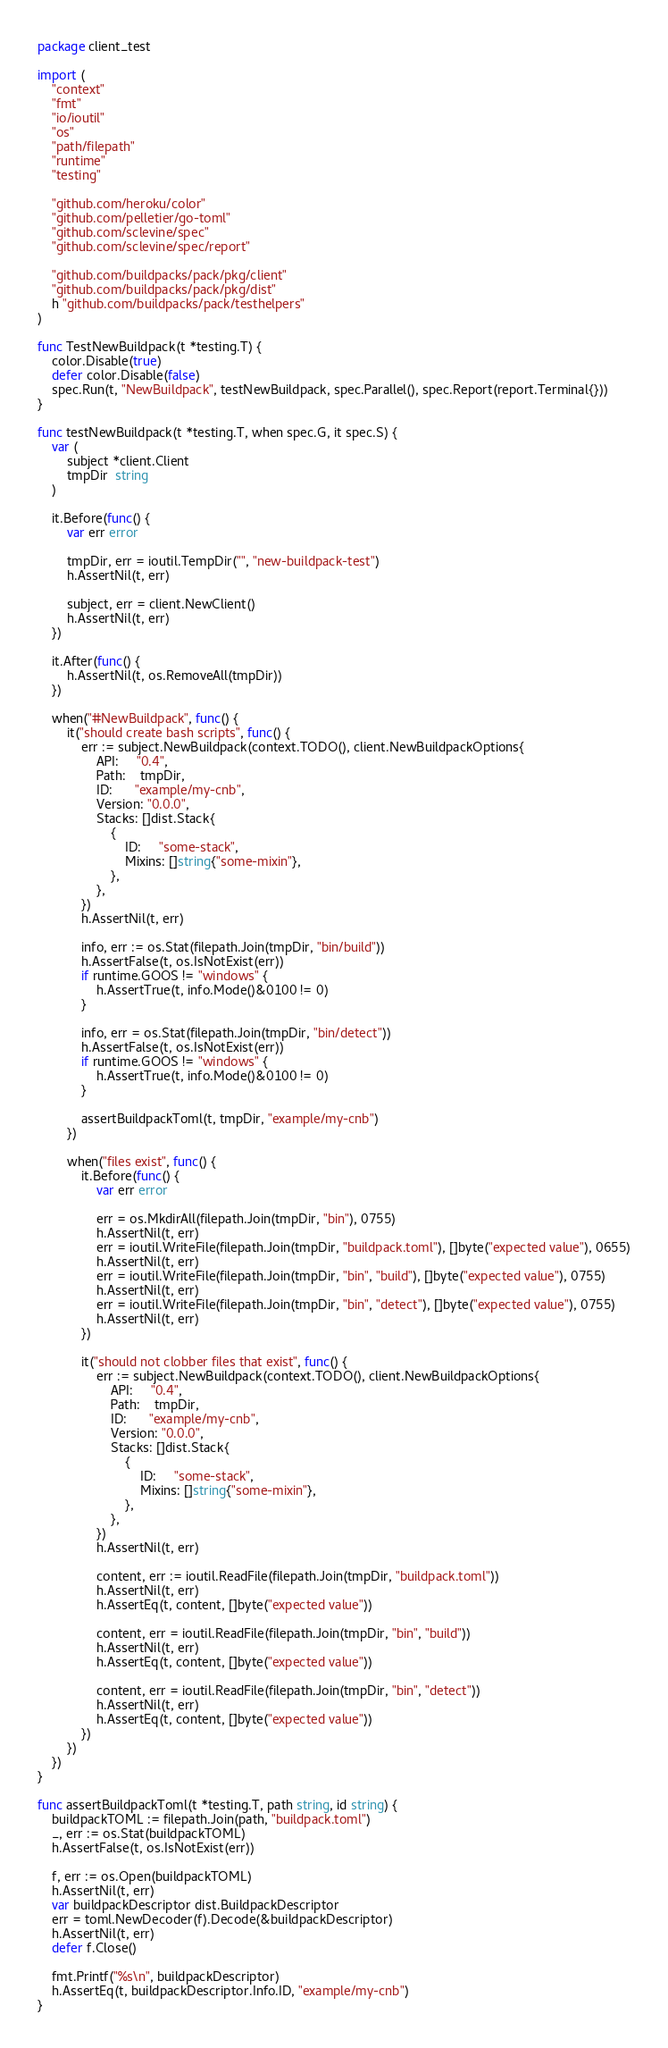Convert code to text. <code><loc_0><loc_0><loc_500><loc_500><_Go_>package client_test

import (
	"context"
	"fmt"
	"io/ioutil"
	"os"
	"path/filepath"
	"runtime"
	"testing"

	"github.com/heroku/color"
	"github.com/pelletier/go-toml"
	"github.com/sclevine/spec"
	"github.com/sclevine/spec/report"

	"github.com/buildpacks/pack/pkg/client"
	"github.com/buildpacks/pack/pkg/dist"
	h "github.com/buildpacks/pack/testhelpers"
)

func TestNewBuildpack(t *testing.T) {
	color.Disable(true)
	defer color.Disable(false)
	spec.Run(t, "NewBuildpack", testNewBuildpack, spec.Parallel(), spec.Report(report.Terminal{}))
}

func testNewBuildpack(t *testing.T, when spec.G, it spec.S) {
	var (
		subject *client.Client
		tmpDir  string
	)

	it.Before(func() {
		var err error

		tmpDir, err = ioutil.TempDir("", "new-buildpack-test")
		h.AssertNil(t, err)

		subject, err = client.NewClient()
		h.AssertNil(t, err)
	})

	it.After(func() {
		h.AssertNil(t, os.RemoveAll(tmpDir))
	})

	when("#NewBuildpack", func() {
		it("should create bash scripts", func() {
			err := subject.NewBuildpack(context.TODO(), client.NewBuildpackOptions{
				API:     "0.4",
				Path:    tmpDir,
				ID:      "example/my-cnb",
				Version: "0.0.0",
				Stacks: []dist.Stack{
					{
						ID:     "some-stack",
						Mixins: []string{"some-mixin"},
					},
				},
			})
			h.AssertNil(t, err)

			info, err := os.Stat(filepath.Join(tmpDir, "bin/build"))
			h.AssertFalse(t, os.IsNotExist(err))
			if runtime.GOOS != "windows" {
				h.AssertTrue(t, info.Mode()&0100 != 0)
			}

			info, err = os.Stat(filepath.Join(tmpDir, "bin/detect"))
			h.AssertFalse(t, os.IsNotExist(err))
			if runtime.GOOS != "windows" {
				h.AssertTrue(t, info.Mode()&0100 != 0)
			}

			assertBuildpackToml(t, tmpDir, "example/my-cnb")
		})

		when("files exist", func() {
			it.Before(func() {
				var err error

				err = os.MkdirAll(filepath.Join(tmpDir, "bin"), 0755)
				h.AssertNil(t, err)
				err = ioutil.WriteFile(filepath.Join(tmpDir, "buildpack.toml"), []byte("expected value"), 0655)
				h.AssertNil(t, err)
				err = ioutil.WriteFile(filepath.Join(tmpDir, "bin", "build"), []byte("expected value"), 0755)
				h.AssertNil(t, err)
				err = ioutil.WriteFile(filepath.Join(tmpDir, "bin", "detect"), []byte("expected value"), 0755)
				h.AssertNil(t, err)
			})

			it("should not clobber files that exist", func() {
				err := subject.NewBuildpack(context.TODO(), client.NewBuildpackOptions{
					API:     "0.4",
					Path:    tmpDir,
					ID:      "example/my-cnb",
					Version: "0.0.0",
					Stacks: []dist.Stack{
						{
							ID:     "some-stack",
							Mixins: []string{"some-mixin"},
						},
					},
				})
				h.AssertNil(t, err)

				content, err := ioutil.ReadFile(filepath.Join(tmpDir, "buildpack.toml"))
				h.AssertNil(t, err)
				h.AssertEq(t, content, []byte("expected value"))

				content, err = ioutil.ReadFile(filepath.Join(tmpDir, "bin", "build"))
				h.AssertNil(t, err)
				h.AssertEq(t, content, []byte("expected value"))

				content, err = ioutil.ReadFile(filepath.Join(tmpDir, "bin", "detect"))
				h.AssertNil(t, err)
				h.AssertEq(t, content, []byte("expected value"))
			})
		})
	})
}

func assertBuildpackToml(t *testing.T, path string, id string) {
	buildpackTOML := filepath.Join(path, "buildpack.toml")
	_, err := os.Stat(buildpackTOML)
	h.AssertFalse(t, os.IsNotExist(err))

	f, err := os.Open(buildpackTOML)
	h.AssertNil(t, err)
	var buildpackDescriptor dist.BuildpackDescriptor
	err = toml.NewDecoder(f).Decode(&buildpackDescriptor)
	h.AssertNil(t, err)
	defer f.Close()

	fmt.Printf("%s\n", buildpackDescriptor)
	h.AssertEq(t, buildpackDescriptor.Info.ID, "example/my-cnb")
}
</code> 